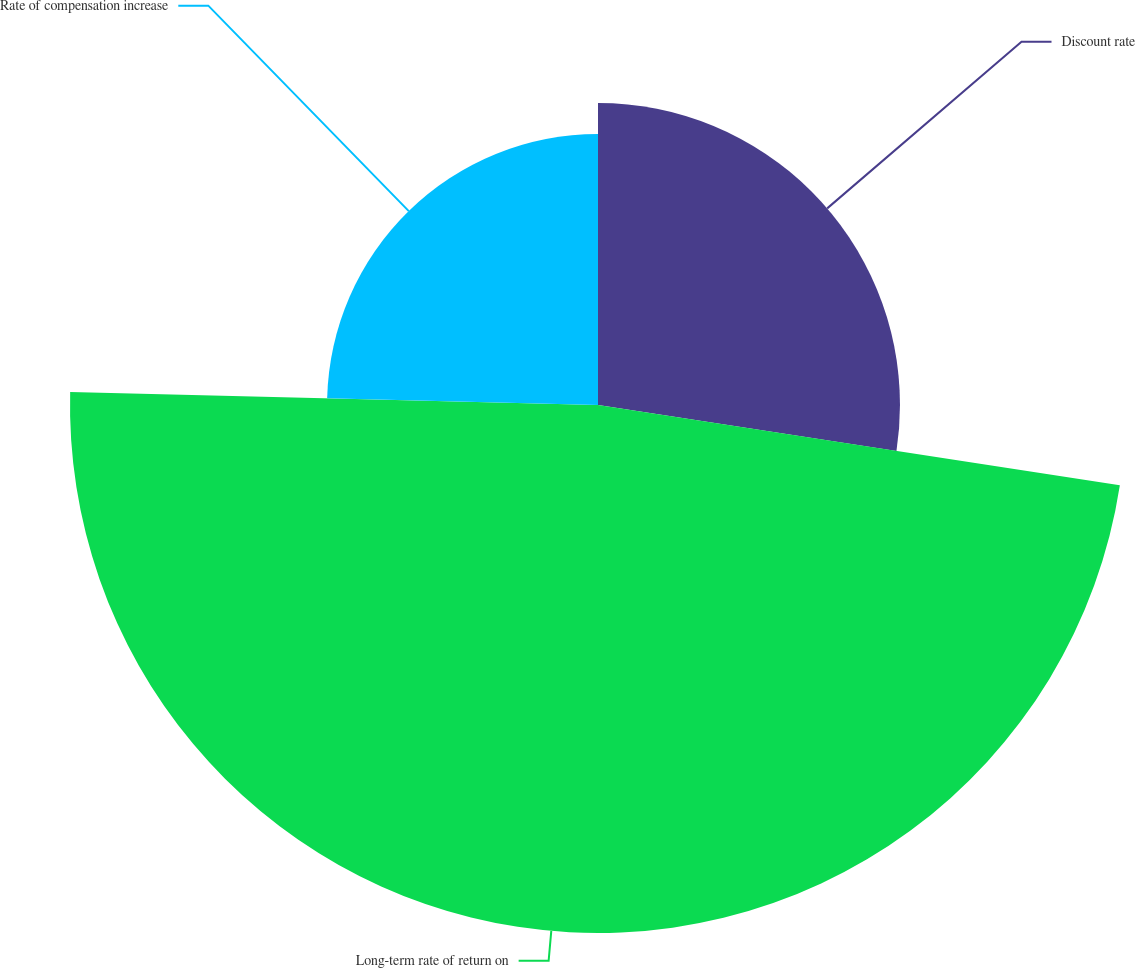Convert chart to OTSL. <chart><loc_0><loc_0><loc_500><loc_500><pie_chart><fcel>Discount rate<fcel>Long-term rate of return on<fcel>Rate of compensation increase<nl><fcel>27.43%<fcel>47.96%<fcel>24.61%<nl></chart> 